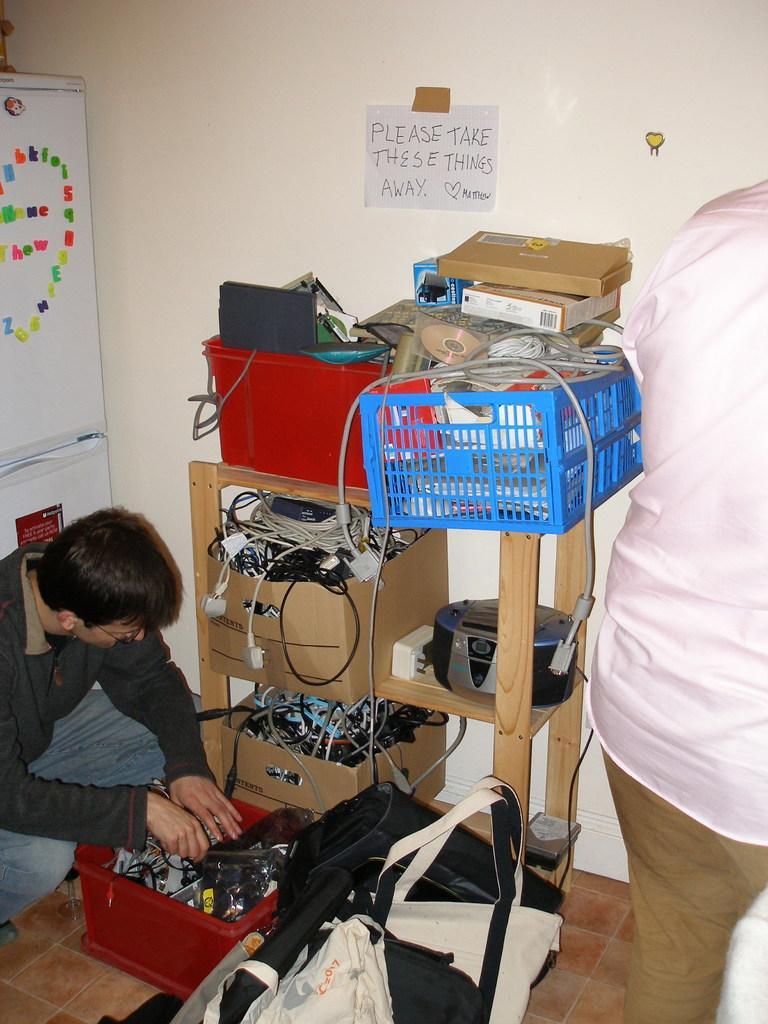Could you give a brief overview of what you see in this image? In the image there is a table, on the table there are some baskets and boxes, in the boxes there are some wires and books. On the right side of the image a person is standing. In the bottom left side of the image a man is sitting. Behind them there is a wall, on the wall there is a poster. Behind him there is a refrigerator. 